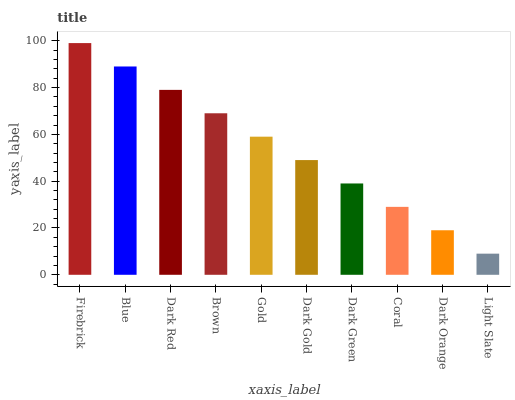Is Light Slate the minimum?
Answer yes or no. Yes. Is Firebrick the maximum?
Answer yes or no. Yes. Is Blue the minimum?
Answer yes or no. No. Is Blue the maximum?
Answer yes or no. No. Is Firebrick greater than Blue?
Answer yes or no. Yes. Is Blue less than Firebrick?
Answer yes or no. Yes. Is Blue greater than Firebrick?
Answer yes or no. No. Is Firebrick less than Blue?
Answer yes or no. No. Is Gold the high median?
Answer yes or no. Yes. Is Dark Gold the low median?
Answer yes or no. Yes. Is Coral the high median?
Answer yes or no. No. Is Dark Orange the low median?
Answer yes or no. No. 